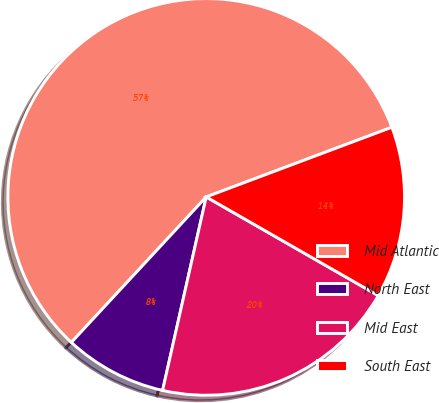Convert chart. <chart><loc_0><loc_0><loc_500><loc_500><pie_chart><fcel>Mid Atlantic<fcel>North East<fcel>Mid East<fcel>South East<nl><fcel>57.38%<fcel>8.37%<fcel>20.24%<fcel>14.0%<nl></chart> 